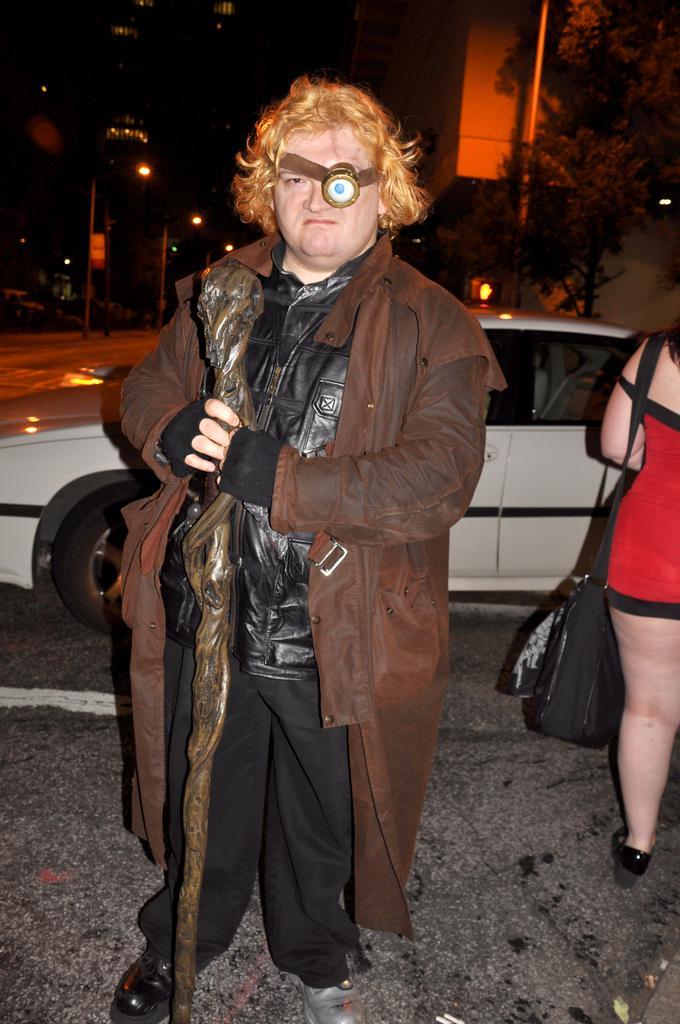Could you give a brief overview of what you see in this image? This person holding a stick and wire jacket. Here we can see another woman wore a bag. Background there are trees, buildings, light poles and vehicle.  